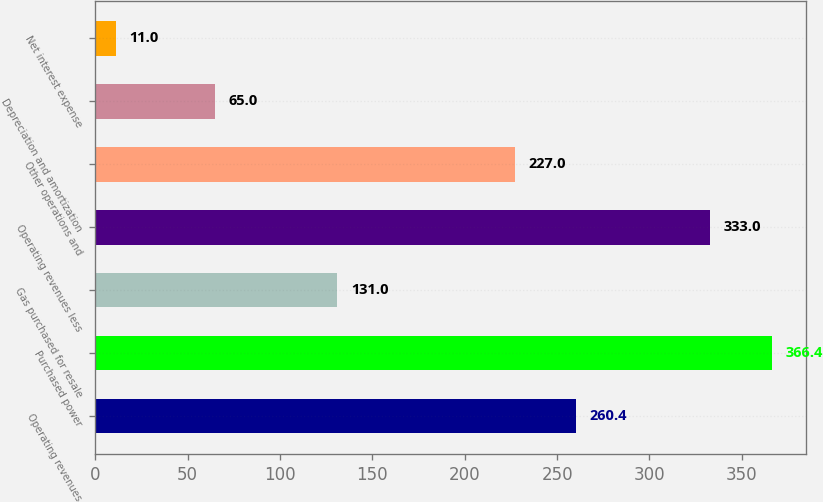<chart> <loc_0><loc_0><loc_500><loc_500><bar_chart><fcel>Operating revenues<fcel>Purchased power<fcel>Gas purchased for resale<fcel>Operating revenues less<fcel>Other operations and<fcel>Depreciation and amortization<fcel>Net interest expense<nl><fcel>260.4<fcel>366.4<fcel>131<fcel>333<fcel>227<fcel>65<fcel>11<nl></chart> 